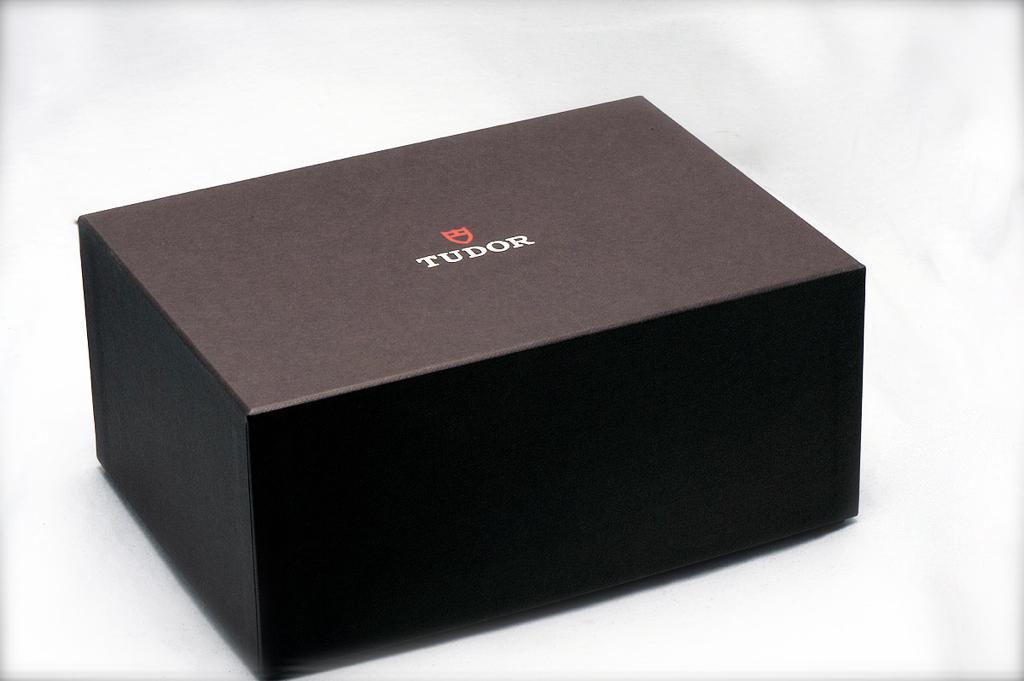What brand of cigars are in the box?
Give a very brief answer. Tudor. 